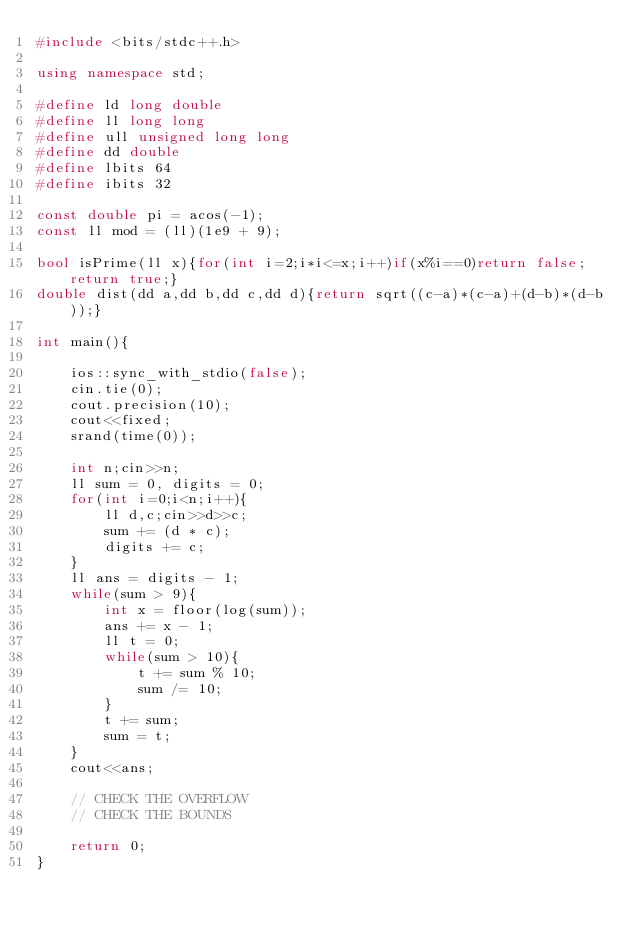Convert code to text. <code><loc_0><loc_0><loc_500><loc_500><_C++_>#include <bits/stdc++.h>
 
using namespace std;
 
#define ld long double
#define ll long long
#define ull unsigned long long
#define dd double
#define lbits 64
#define ibits 32

const double pi = acos(-1);
const ll mod = (ll)(1e9 + 9);

bool isPrime(ll x){for(int i=2;i*i<=x;i++)if(x%i==0)return false;return true;}
double dist(dd a,dd b,dd c,dd d){return sqrt((c-a)*(c-a)+(d-b)*(d-b));}

int main(){

    ios::sync_with_stdio(false);
    cin.tie(0);
    cout.precision(10);
    cout<<fixed;
    srand(time(0));

    int n;cin>>n;
    ll sum = 0, digits = 0;
    for(int i=0;i<n;i++){
        ll d,c;cin>>d>>c;
        sum += (d * c);
        digits += c;
    }
    ll ans = digits - 1;
    while(sum > 9){
        int x = floor(log(sum));
        ans += x - 1;
        ll t = 0;
        while(sum > 10){
            t += sum % 10;
            sum /= 10;
        }
        t += sum;
        sum = t;
    }
    cout<<ans;

    // CHECK THE OVERFLOW
    // CHECK THE BOUNDS

    return 0;
}</code> 